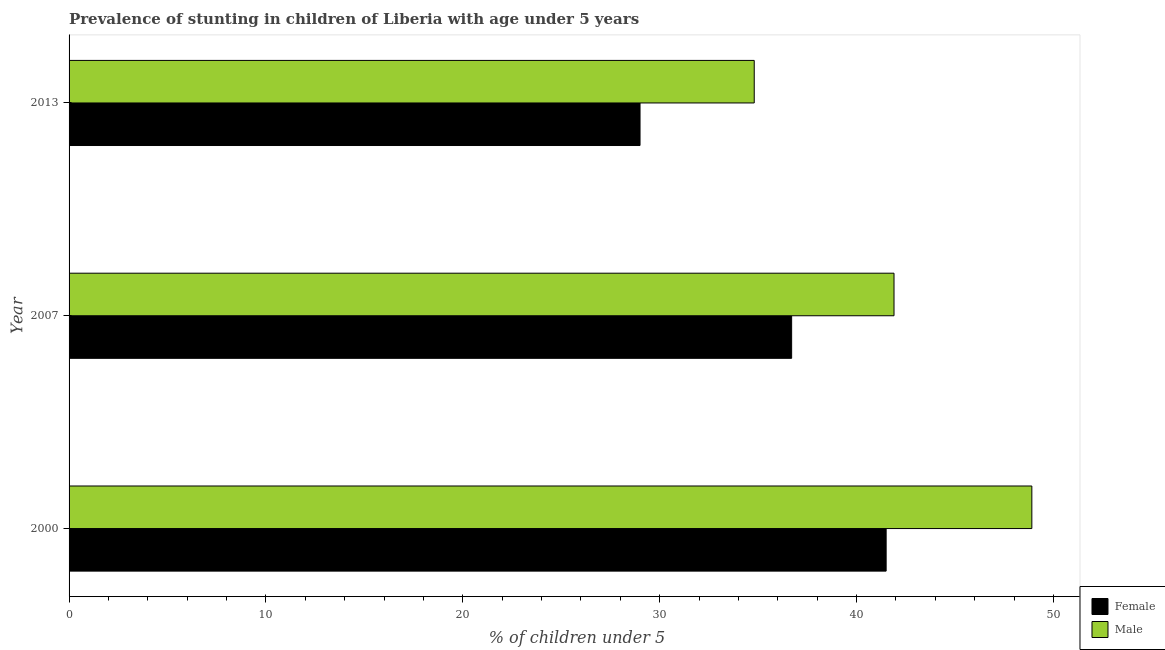How many groups of bars are there?
Give a very brief answer. 3. How many bars are there on the 1st tick from the top?
Keep it short and to the point. 2. How many bars are there on the 1st tick from the bottom?
Make the answer very short. 2. In how many cases, is the number of bars for a given year not equal to the number of legend labels?
Give a very brief answer. 0. What is the percentage of stunted male children in 2007?
Offer a terse response. 41.9. Across all years, what is the maximum percentage of stunted male children?
Offer a terse response. 48.9. Across all years, what is the minimum percentage of stunted male children?
Give a very brief answer. 34.8. In which year was the percentage of stunted male children maximum?
Make the answer very short. 2000. In which year was the percentage of stunted male children minimum?
Offer a very short reply. 2013. What is the total percentage of stunted female children in the graph?
Provide a short and direct response. 107.2. What is the difference between the percentage of stunted female children in 2007 and the percentage of stunted male children in 2013?
Give a very brief answer. 1.9. What is the average percentage of stunted male children per year?
Offer a very short reply. 41.87. What is the ratio of the percentage of stunted female children in 2000 to that in 2007?
Offer a terse response. 1.13. What is the difference between the highest and the second highest percentage of stunted male children?
Provide a short and direct response. 7. What does the 2nd bar from the top in 2000 represents?
Offer a terse response. Female. What does the 2nd bar from the bottom in 2007 represents?
Offer a very short reply. Male. Does the graph contain any zero values?
Keep it short and to the point. No. How are the legend labels stacked?
Make the answer very short. Vertical. What is the title of the graph?
Your response must be concise. Prevalence of stunting in children of Liberia with age under 5 years. What is the label or title of the X-axis?
Your answer should be compact.  % of children under 5. What is the label or title of the Y-axis?
Your answer should be very brief. Year. What is the  % of children under 5 of Female in 2000?
Give a very brief answer. 41.5. What is the  % of children under 5 in Male in 2000?
Your answer should be compact. 48.9. What is the  % of children under 5 of Female in 2007?
Provide a succinct answer. 36.7. What is the  % of children under 5 in Male in 2007?
Keep it short and to the point. 41.9. What is the  % of children under 5 of Female in 2013?
Provide a short and direct response. 29. What is the  % of children under 5 in Male in 2013?
Provide a succinct answer. 34.8. Across all years, what is the maximum  % of children under 5 in Female?
Your answer should be compact. 41.5. Across all years, what is the maximum  % of children under 5 in Male?
Your answer should be very brief. 48.9. Across all years, what is the minimum  % of children under 5 of Male?
Your answer should be very brief. 34.8. What is the total  % of children under 5 of Female in the graph?
Make the answer very short. 107.2. What is the total  % of children under 5 in Male in the graph?
Your response must be concise. 125.6. What is the difference between the  % of children under 5 in Female in 2000 and that in 2007?
Ensure brevity in your answer.  4.8. What is the difference between the  % of children under 5 of Female in 2000 and that in 2013?
Your answer should be compact. 12.5. What is the difference between the  % of children under 5 of Male in 2000 and that in 2013?
Offer a very short reply. 14.1. What is the difference between the  % of children under 5 of Female in 2007 and that in 2013?
Ensure brevity in your answer.  7.7. What is the difference between the  % of children under 5 in Female in 2000 and the  % of children under 5 in Male in 2007?
Provide a short and direct response. -0.4. What is the difference between the  % of children under 5 of Female in 2000 and the  % of children under 5 of Male in 2013?
Offer a very short reply. 6.7. What is the difference between the  % of children under 5 in Female in 2007 and the  % of children under 5 in Male in 2013?
Keep it short and to the point. 1.9. What is the average  % of children under 5 of Female per year?
Provide a succinct answer. 35.73. What is the average  % of children under 5 in Male per year?
Offer a very short reply. 41.87. In the year 2000, what is the difference between the  % of children under 5 of Female and  % of children under 5 of Male?
Your answer should be compact. -7.4. In the year 2007, what is the difference between the  % of children under 5 of Female and  % of children under 5 of Male?
Provide a short and direct response. -5.2. In the year 2013, what is the difference between the  % of children under 5 in Female and  % of children under 5 in Male?
Provide a short and direct response. -5.8. What is the ratio of the  % of children under 5 in Female in 2000 to that in 2007?
Provide a short and direct response. 1.13. What is the ratio of the  % of children under 5 of Male in 2000 to that in 2007?
Provide a short and direct response. 1.17. What is the ratio of the  % of children under 5 in Female in 2000 to that in 2013?
Offer a terse response. 1.43. What is the ratio of the  % of children under 5 in Male in 2000 to that in 2013?
Provide a succinct answer. 1.41. What is the ratio of the  % of children under 5 of Female in 2007 to that in 2013?
Your answer should be very brief. 1.27. What is the ratio of the  % of children under 5 in Male in 2007 to that in 2013?
Keep it short and to the point. 1.2. What is the difference between the highest and the lowest  % of children under 5 of Female?
Give a very brief answer. 12.5. What is the difference between the highest and the lowest  % of children under 5 of Male?
Make the answer very short. 14.1. 